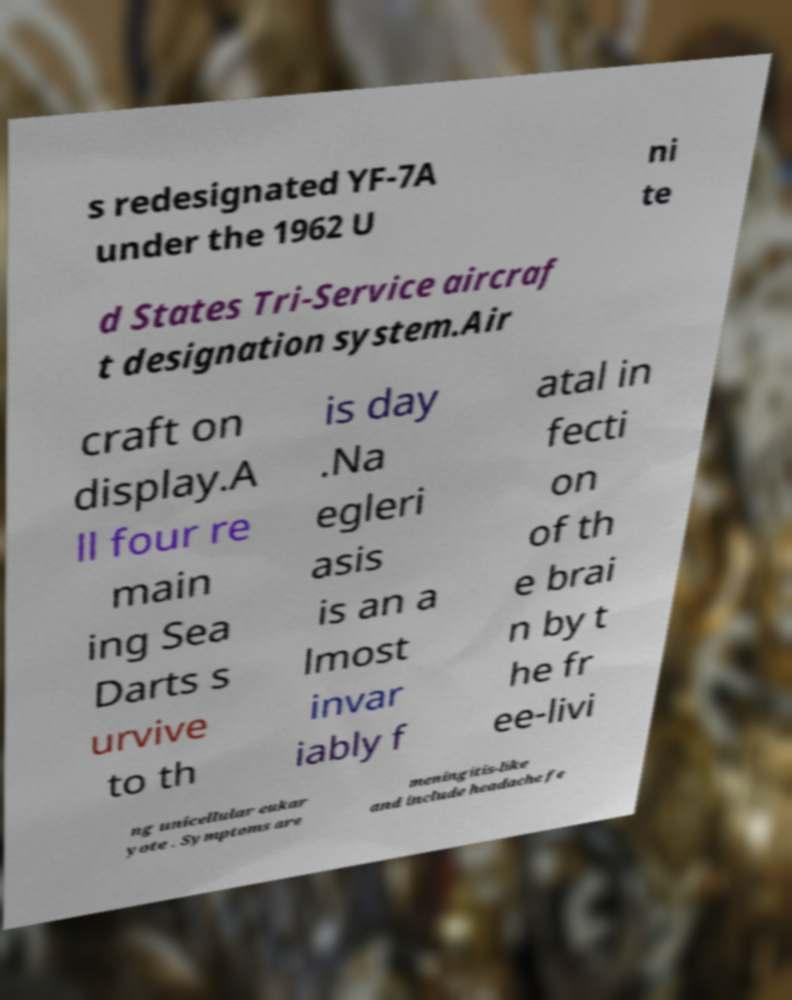Can you accurately transcribe the text from the provided image for me? s redesignated YF-7A under the 1962 U ni te d States Tri-Service aircraf t designation system.Air craft on display.A ll four re main ing Sea Darts s urvive to th is day .Na egleri asis is an a lmost invar iably f atal in fecti on of th e brai n by t he fr ee-livi ng unicellular eukar yote . Symptoms are meningitis-like and include headache fe 